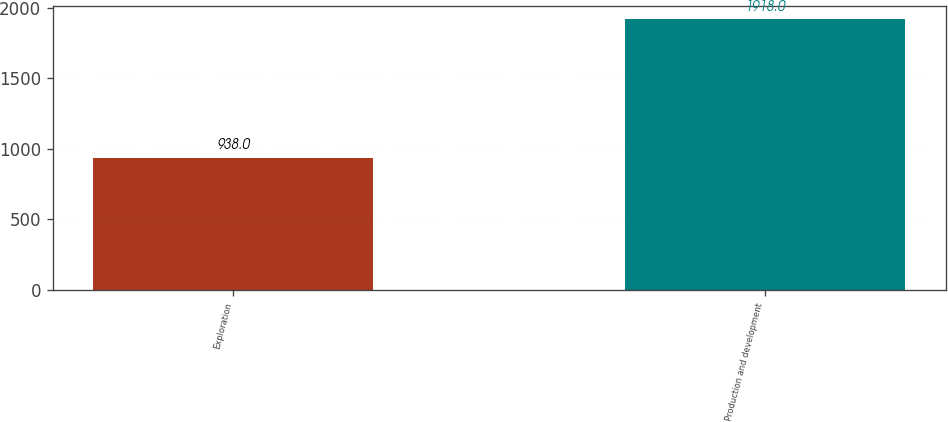Convert chart to OTSL. <chart><loc_0><loc_0><loc_500><loc_500><bar_chart><fcel>Exploration<fcel>Production and development<nl><fcel>938<fcel>1918<nl></chart> 